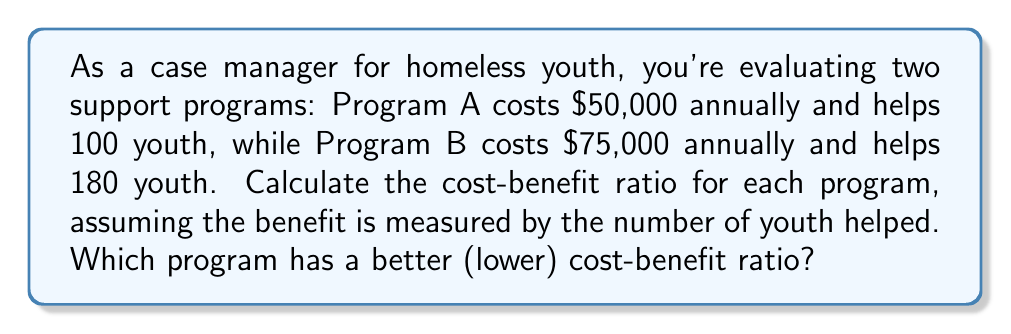Can you answer this question? To solve this problem, we need to calculate the cost-benefit ratio for each program and compare them. The cost-benefit ratio is calculated by dividing the cost by the benefit (number of youth helped).

For Program A:
Cost = $50,000
Benefit = 100 youth
Cost-benefit ratio = $\frac{\text{Cost}}{\text{Benefit}} = \frac{50000}{100} = 500$

For Program B:
Cost = $75,000
Benefit = 180 youth
Cost-benefit ratio = $\frac{\text{Cost}}{\text{Benefit}} = \frac{75000}{180} = 416.67$

To compare the ratios:
Program A: $500 per youth
Program B: $416.67 per youth

Since a lower cost-benefit ratio indicates better efficiency, Program B has a better (lower) cost-benefit ratio.
Answer: Program B; $416.67 per youth 